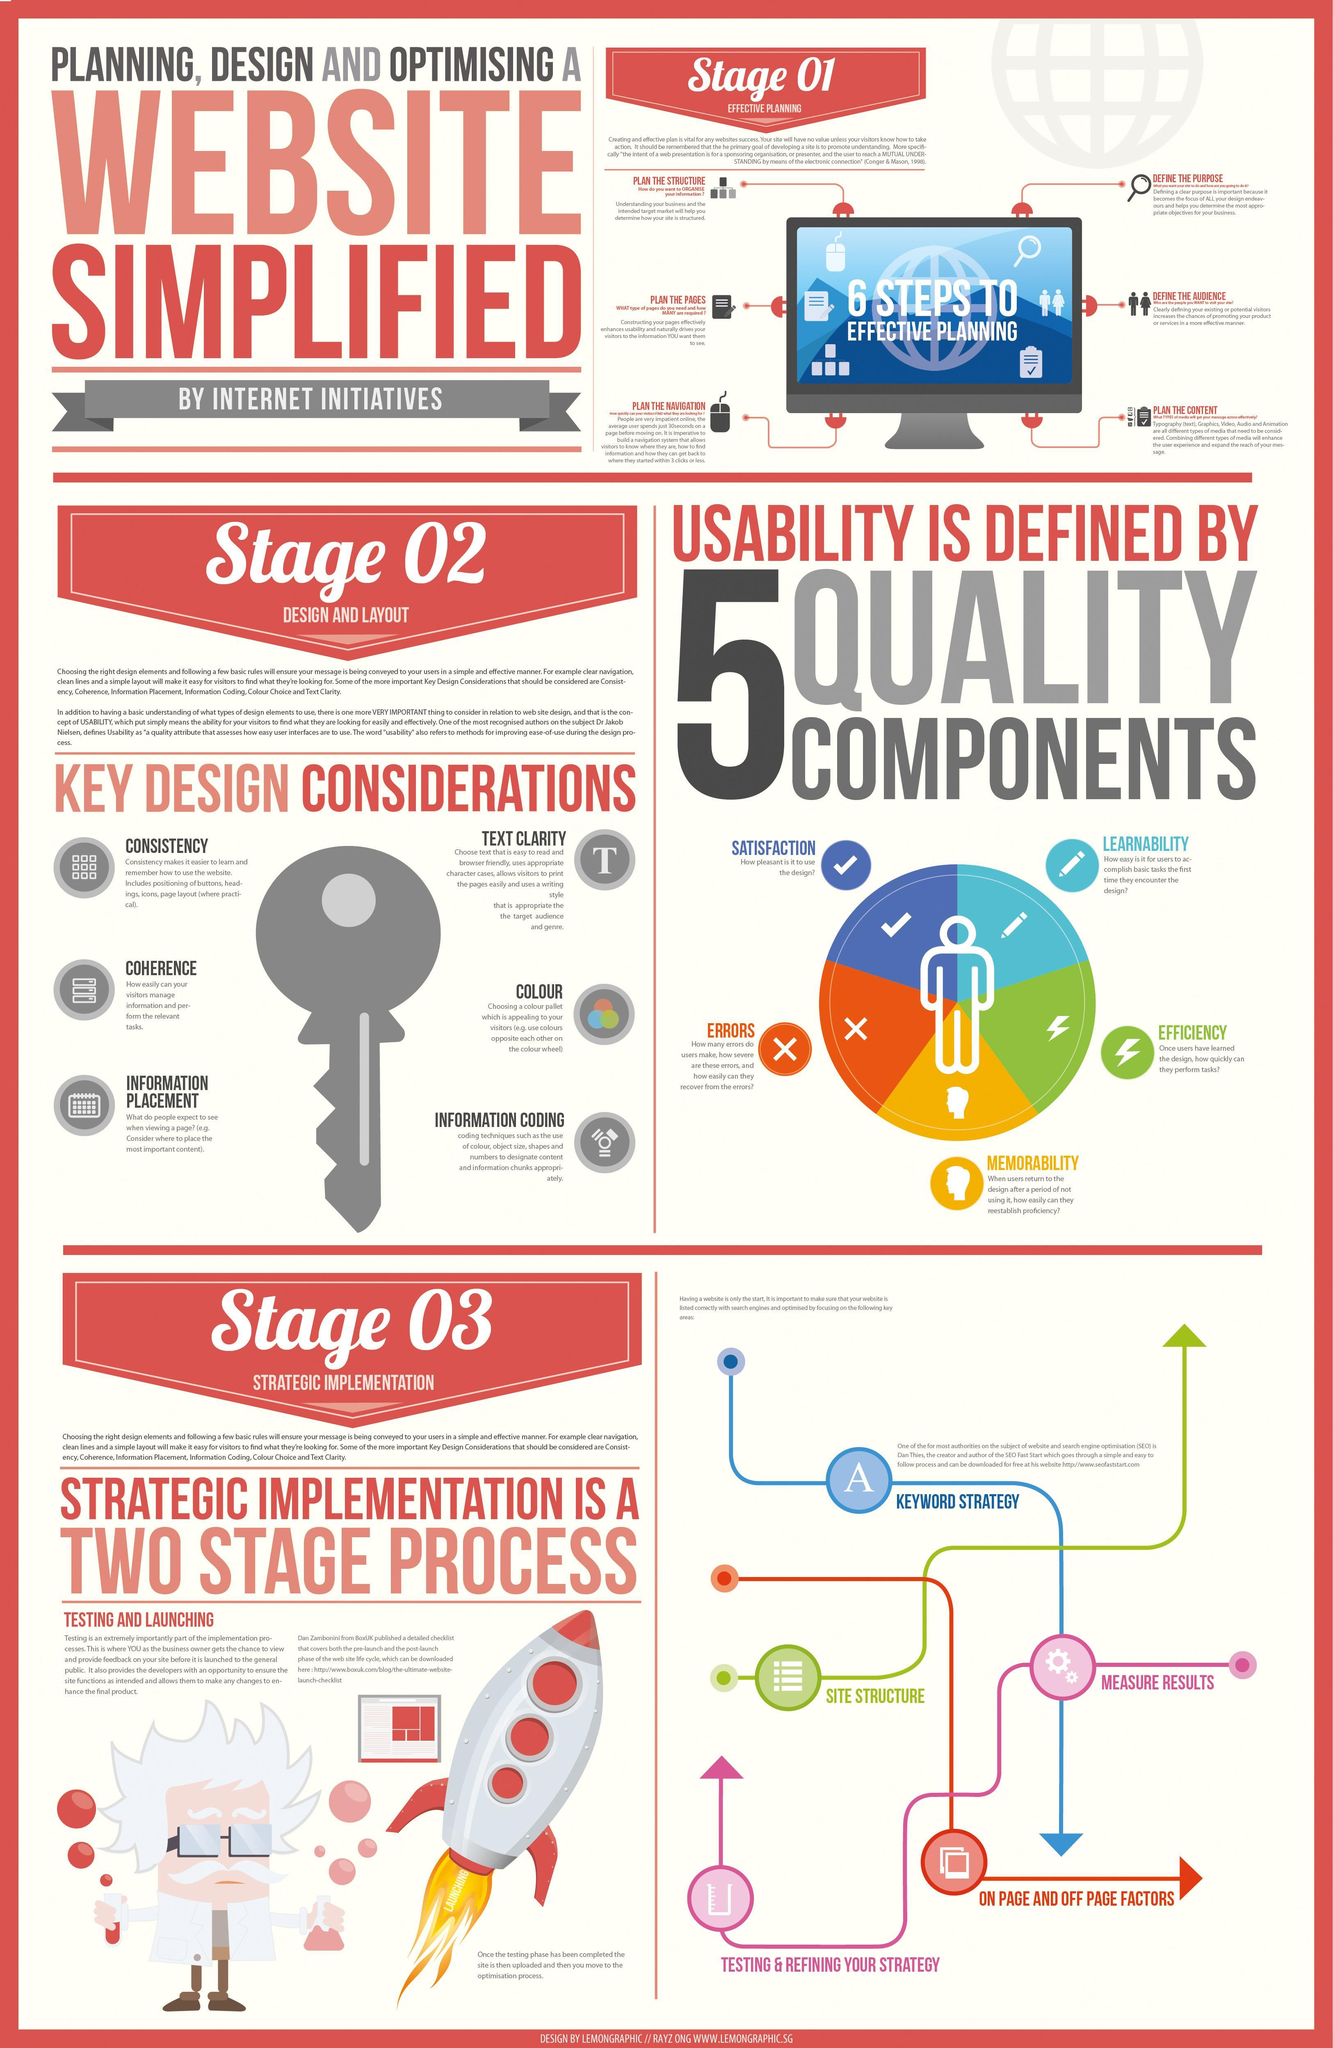how many key design considerations are there?
Answer the question with a short phrase. 6 Which stage does the rocket show? launching which quality component has the icon of a pen in it? learnability what is the colour of the key, grey or white? grey what is the key design consideration to enable visitor to manage information coherence which quality component is shown in red? error 